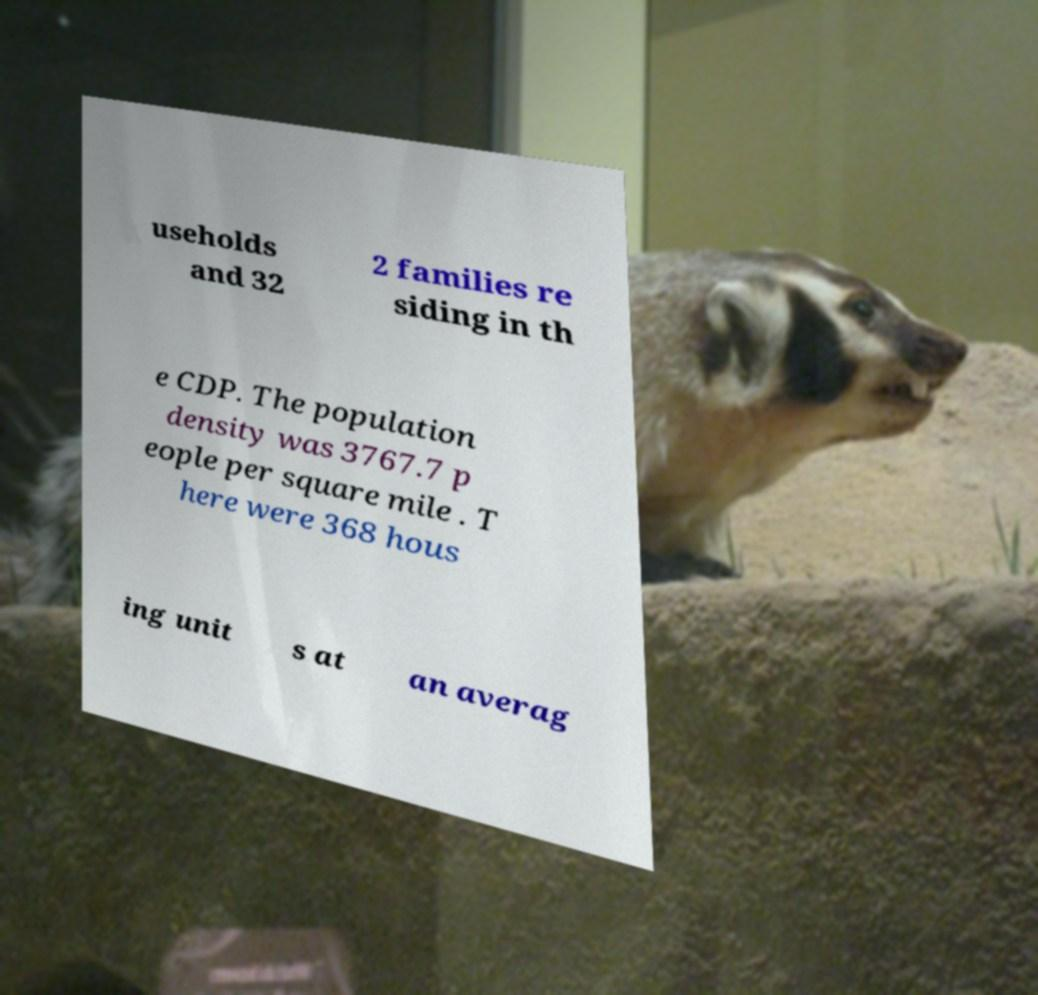Could you assist in decoding the text presented in this image and type it out clearly? useholds and 32 2 families re siding in th e CDP. The population density was 3767.7 p eople per square mile . T here were 368 hous ing unit s at an averag 